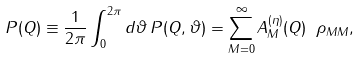<formula> <loc_0><loc_0><loc_500><loc_500>P ( Q ) \equiv \frac { 1 } { 2 \pi } \int ^ { 2 \pi } _ { 0 } d \vartheta \, P ( Q , \vartheta ) = \sum _ { M = 0 } ^ { \infty } A _ { M } ^ { ( \eta ) } ( Q ) \ \rho _ { M M } ,</formula> 